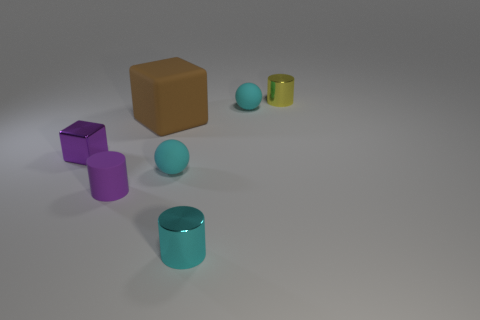Subtract all matte cylinders. How many cylinders are left? 2 Add 1 large red metal spheres. How many objects exist? 8 Subtract all yellow cylinders. How many cylinders are left? 2 Subtract all spheres. How many objects are left? 5 Subtract all brown cylinders. Subtract all cyan balls. How many cylinders are left? 3 Subtract all tiny matte things. Subtract all small balls. How many objects are left? 2 Add 3 small rubber objects. How many small rubber objects are left? 6 Add 2 large gray rubber cylinders. How many large gray rubber cylinders exist? 2 Subtract 0 yellow balls. How many objects are left? 7 Subtract 1 blocks. How many blocks are left? 1 